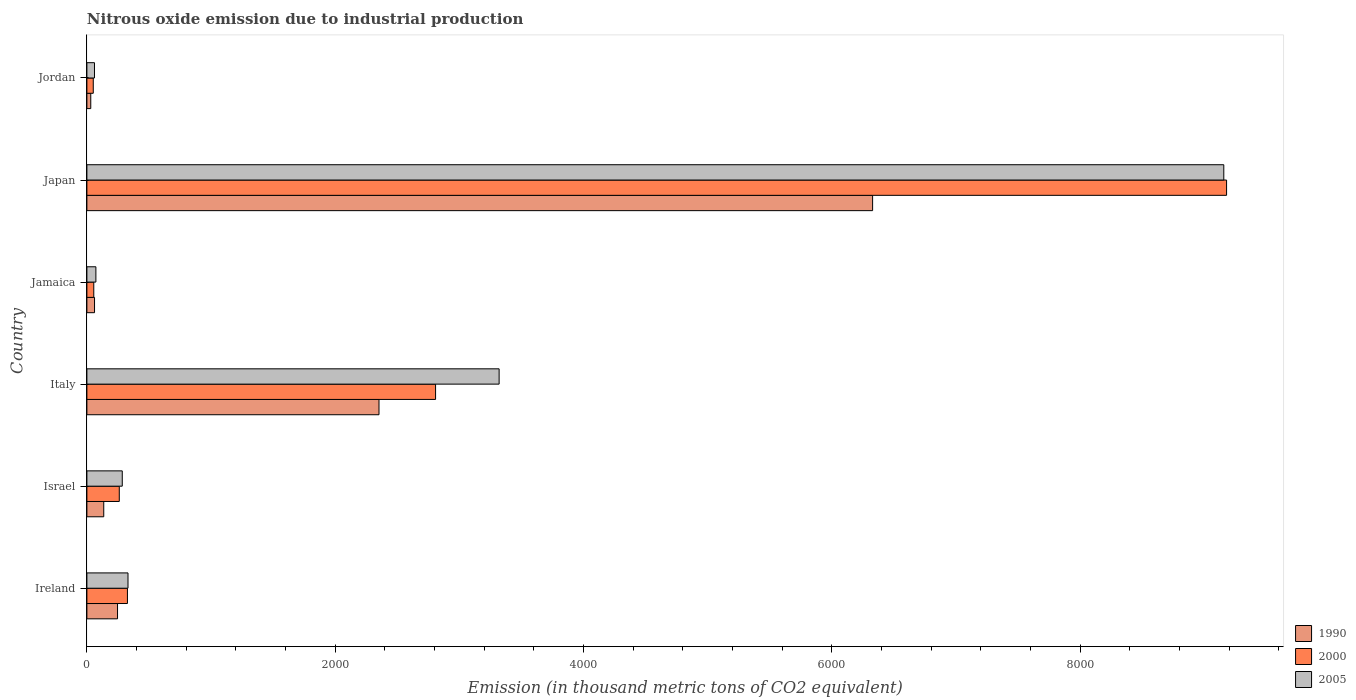How many groups of bars are there?
Your response must be concise. 6. Are the number of bars per tick equal to the number of legend labels?
Provide a succinct answer. Yes. Are the number of bars on each tick of the Y-axis equal?
Give a very brief answer. Yes. How many bars are there on the 5th tick from the top?
Your response must be concise. 3. In how many cases, is the number of bars for a given country not equal to the number of legend labels?
Offer a terse response. 0. What is the amount of nitrous oxide emitted in 2000 in Ireland?
Your answer should be very brief. 326.6. Across all countries, what is the maximum amount of nitrous oxide emitted in 1990?
Your answer should be very brief. 6328.4. Across all countries, what is the minimum amount of nitrous oxide emitted in 2005?
Keep it short and to the point. 61.1. In which country was the amount of nitrous oxide emitted in 2000 minimum?
Provide a succinct answer. Jordan. What is the total amount of nitrous oxide emitted in 1990 in the graph?
Provide a short and direct response. 9156.3. What is the difference between the amount of nitrous oxide emitted in 2000 in Italy and that in Japan?
Your answer should be compact. -6371. What is the difference between the amount of nitrous oxide emitted in 2000 in Japan and the amount of nitrous oxide emitted in 2005 in Jamaica?
Offer a terse response. 9107. What is the average amount of nitrous oxide emitted in 2000 per country?
Offer a very short reply. 2113.67. What is the difference between the amount of nitrous oxide emitted in 2000 and amount of nitrous oxide emitted in 1990 in Japan?
Your response must be concise. 2851. In how many countries, is the amount of nitrous oxide emitted in 2005 greater than 8400 thousand metric tons?
Your response must be concise. 1. What is the ratio of the amount of nitrous oxide emitted in 1990 in Israel to that in Jamaica?
Your answer should be very brief. 2.21. Is the amount of nitrous oxide emitted in 1990 in Ireland less than that in Jamaica?
Provide a short and direct response. No. What is the difference between the highest and the second highest amount of nitrous oxide emitted in 1990?
Offer a very short reply. 3975.7. What is the difference between the highest and the lowest amount of nitrous oxide emitted in 1990?
Offer a terse response. 6297.2. What does the 2nd bar from the top in Ireland represents?
Offer a very short reply. 2000. What does the 2nd bar from the bottom in Jamaica represents?
Your answer should be very brief. 2000. Is it the case that in every country, the sum of the amount of nitrous oxide emitted in 2005 and amount of nitrous oxide emitted in 1990 is greater than the amount of nitrous oxide emitted in 2000?
Your response must be concise. Yes. How many bars are there?
Provide a short and direct response. 18. How many countries are there in the graph?
Your answer should be compact. 6. What is the difference between two consecutive major ticks on the X-axis?
Offer a very short reply. 2000. Are the values on the major ticks of X-axis written in scientific E-notation?
Provide a short and direct response. No. Does the graph contain any zero values?
Provide a short and direct response. No. How are the legend labels stacked?
Offer a very short reply. Vertical. What is the title of the graph?
Offer a terse response. Nitrous oxide emission due to industrial production. Does "1966" appear as one of the legend labels in the graph?
Offer a very short reply. No. What is the label or title of the X-axis?
Your answer should be compact. Emission (in thousand metric tons of CO2 equivalent). What is the Emission (in thousand metric tons of CO2 equivalent) in 1990 in Ireland?
Your answer should be very brief. 246.7. What is the Emission (in thousand metric tons of CO2 equivalent) in 2000 in Ireland?
Ensure brevity in your answer.  326.6. What is the Emission (in thousand metric tons of CO2 equivalent) of 2005 in Ireland?
Ensure brevity in your answer.  331.1. What is the Emission (in thousand metric tons of CO2 equivalent) of 1990 in Israel?
Offer a very short reply. 135.8. What is the Emission (in thousand metric tons of CO2 equivalent) of 2000 in Israel?
Your answer should be very brief. 260.8. What is the Emission (in thousand metric tons of CO2 equivalent) of 2005 in Israel?
Make the answer very short. 284.9. What is the Emission (in thousand metric tons of CO2 equivalent) of 1990 in Italy?
Provide a succinct answer. 2352.7. What is the Emission (in thousand metric tons of CO2 equivalent) in 2000 in Italy?
Your answer should be compact. 2808.4. What is the Emission (in thousand metric tons of CO2 equivalent) in 2005 in Italy?
Ensure brevity in your answer.  3320.3. What is the Emission (in thousand metric tons of CO2 equivalent) in 1990 in Jamaica?
Your response must be concise. 61.5. What is the Emission (in thousand metric tons of CO2 equivalent) of 2000 in Jamaica?
Provide a short and direct response. 55.5. What is the Emission (in thousand metric tons of CO2 equivalent) in 2005 in Jamaica?
Your answer should be compact. 72.4. What is the Emission (in thousand metric tons of CO2 equivalent) of 1990 in Japan?
Your answer should be very brief. 6328.4. What is the Emission (in thousand metric tons of CO2 equivalent) of 2000 in Japan?
Offer a terse response. 9179.4. What is the Emission (in thousand metric tons of CO2 equivalent) in 2005 in Japan?
Ensure brevity in your answer.  9157. What is the Emission (in thousand metric tons of CO2 equivalent) of 1990 in Jordan?
Provide a succinct answer. 31.2. What is the Emission (in thousand metric tons of CO2 equivalent) in 2000 in Jordan?
Keep it short and to the point. 51.3. What is the Emission (in thousand metric tons of CO2 equivalent) of 2005 in Jordan?
Your response must be concise. 61.1. Across all countries, what is the maximum Emission (in thousand metric tons of CO2 equivalent) of 1990?
Provide a short and direct response. 6328.4. Across all countries, what is the maximum Emission (in thousand metric tons of CO2 equivalent) of 2000?
Offer a very short reply. 9179.4. Across all countries, what is the maximum Emission (in thousand metric tons of CO2 equivalent) in 2005?
Provide a short and direct response. 9157. Across all countries, what is the minimum Emission (in thousand metric tons of CO2 equivalent) of 1990?
Provide a succinct answer. 31.2. Across all countries, what is the minimum Emission (in thousand metric tons of CO2 equivalent) of 2000?
Your answer should be compact. 51.3. Across all countries, what is the minimum Emission (in thousand metric tons of CO2 equivalent) of 2005?
Provide a succinct answer. 61.1. What is the total Emission (in thousand metric tons of CO2 equivalent) of 1990 in the graph?
Offer a very short reply. 9156.3. What is the total Emission (in thousand metric tons of CO2 equivalent) in 2000 in the graph?
Keep it short and to the point. 1.27e+04. What is the total Emission (in thousand metric tons of CO2 equivalent) in 2005 in the graph?
Keep it short and to the point. 1.32e+04. What is the difference between the Emission (in thousand metric tons of CO2 equivalent) in 1990 in Ireland and that in Israel?
Your response must be concise. 110.9. What is the difference between the Emission (in thousand metric tons of CO2 equivalent) in 2000 in Ireland and that in Israel?
Offer a very short reply. 65.8. What is the difference between the Emission (in thousand metric tons of CO2 equivalent) in 2005 in Ireland and that in Israel?
Your answer should be compact. 46.2. What is the difference between the Emission (in thousand metric tons of CO2 equivalent) of 1990 in Ireland and that in Italy?
Offer a very short reply. -2106. What is the difference between the Emission (in thousand metric tons of CO2 equivalent) in 2000 in Ireland and that in Italy?
Provide a short and direct response. -2481.8. What is the difference between the Emission (in thousand metric tons of CO2 equivalent) in 2005 in Ireland and that in Italy?
Your response must be concise. -2989.2. What is the difference between the Emission (in thousand metric tons of CO2 equivalent) in 1990 in Ireland and that in Jamaica?
Your response must be concise. 185.2. What is the difference between the Emission (in thousand metric tons of CO2 equivalent) in 2000 in Ireland and that in Jamaica?
Your answer should be compact. 271.1. What is the difference between the Emission (in thousand metric tons of CO2 equivalent) in 2005 in Ireland and that in Jamaica?
Provide a succinct answer. 258.7. What is the difference between the Emission (in thousand metric tons of CO2 equivalent) of 1990 in Ireland and that in Japan?
Provide a short and direct response. -6081.7. What is the difference between the Emission (in thousand metric tons of CO2 equivalent) of 2000 in Ireland and that in Japan?
Provide a short and direct response. -8852.8. What is the difference between the Emission (in thousand metric tons of CO2 equivalent) in 2005 in Ireland and that in Japan?
Give a very brief answer. -8825.9. What is the difference between the Emission (in thousand metric tons of CO2 equivalent) in 1990 in Ireland and that in Jordan?
Your answer should be compact. 215.5. What is the difference between the Emission (in thousand metric tons of CO2 equivalent) in 2000 in Ireland and that in Jordan?
Ensure brevity in your answer.  275.3. What is the difference between the Emission (in thousand metric tons of CO2 equivalent) in 2005 in Ireland and that in Jordan?
Ensure brevity in your answer.  270. What is the difference between the Emission (in thousand metric tons of CO2 equivalent) in 1990 in Israel and that in Italy?
Your answer should be very brief. -2216.9. What is the difference between the Emission (in thousand metric tons of CO2 equivalent) in 2000 in Israel and that in Italy?
Keep it short and to the point. -2547.6. What is the difference between the Emission (in thousand metric tons of CO2 equivalent) of 2005 in Israel and that in Italy?
Keep it short and to the point. -3035.4. What is the difference between the Emission (in thousand metric tons of CO2 equivalent) in 1990 in Israel and that in Jamaica?
Provide a short and direct response. 74.3. What is the difference between the Emission (in thousand metric tons of CO2 equivalent) of 2000 in Israel and that in Jamaica?
Your answer should be compact. 205.3. What is the difference between the Emission (in thousand metric tons of CO2 equivalent) of 2005 in Israel and that in Jamaica?
Your answer should be very brief. 212.5. What is the difference between the Emission (in thousand metric tons of CO2 equivalent) in 1990 in Israel and that in Japan?
Provide a short and direct response. -6192.6. What is the difference between the Emission (in thousand metric tons of CO2 equivalent) of 2000 in Israel and that in Japan?
Offer a terse response. -8918.6. What is the difference between the Emission (in thousand metric tons of CO2 equivalent) of 2005 in Israel and that in Japan?
Provide a succinct answer. -8872.1. What is the difference between the Emission (in thousand metric tons of CO2 equivalent) in 1990 in Israel and that in Jordan?
Your response must be concise. 104.6. What is the difference between the Emission (in thousand metric tons of CO2 equivalent) of 2000 in Israel and that in Jordan?
Your answer should be very brief. 209.5. What is the difference between the Emission (in thousand metric tons of CO2 equivalent) of 2005 in Israel and that in Jordan?
Ensure brevity in your answer.  223.8. What is the difference between the Emission (in thousand metric tons of CO2 equivalent) of 1990 in Italy and that in Jamaica?
Your response must be concise. 2291.2. What is the difference between the Emission (in thousand metric tons of CO2 equivalent) in 2000 in Italy and that in Jamaica?
Ensure brevity in your answer.  2752.9. What is the difference between the Emission (in thousand metric tons of CO2 equivalent) in 2005 in Italy and that in Jamaica?
Keep it short and to the point. 3247.9. What is the difference between the Emission (in thousand metric tons of CO2 equivalent) in 1990 in Italy and that in Japan?
Your answer should be very brief. -3975.7. What is the difference between the Emission (in thousand metric tons of CO2 equivalent) of 2000 in Italy and that in Japan?
Your answer should be compact. -6371. What is the difference between the Emission (in thousand metric tons of CO2 equivalent) in 2005 in Italy and that in Japan?
Make the answer very short. -5836.7. What is the difference between the Emission (in thousand metric tons of CO2 equivalent) of 1990 in Italy and that in Jordan?
Make the answer very short. 2321.5. What is the difference between the Emission (in thousand metric tons of CO2 equivalent) in 2000 in Italy and that in Jordan?
Ensure brevity in your answer.  2757.1. What is the difference between the Emission (in thousand metric tons of CO2 equivalent) in 2005 in Italy and that in Jordan?
Provide a short and direct response. 3259.2. What is the difference between the Emission (in thousand metric tons of CO2 equivalent) of 1990 in Jamaica and that in Japan?
Your answer should be compact. -6266.9. What is the difference between the Emission (in thousand metric tons of CO2 equivalent) of 2000 in Jamaica and that in Japan?
Your answer should be compact. -9123.9. What is the difference between the Emission (in thousand metric tons of CO2 equivalent) in 2005 in Jamaica and that in Japan?
Give a very brief answer. -9084.6. What is the difference between the Emission (in thousand metric tons of CO2 equivalent) in 1990 in Jamaica and that in Jordan?
Ensure brevity in your answer.  30.3. What is the difference between the Emission (in thousand metric tons of CO2 equivalent) in 1990 in Japan and that in Jordan?
Offer a terse response. 6297.2. What is the difference between the Emission (in thousand metric tons of CO2 equivalent) of 2000 in Japan and that in Jordan?
Give a very brief answer. 9128.1. What is the difference between the Emission (in thousand metric tons of CO2 equivalent) of 2005 in Japan and that in Jordan?
Offer a terse response. 9095.9. What is the difference between the Emission (in thousand metric tons of CO2 equivalent) in 1990 in Ireland and the Emission (in thousand metric tons of CO2 equivalent) in 2000 in Israel?
Your answer should be very brief. -14.1. What is the difference between the Emission (in thousand metric tons of CO2 equivalent) of 1990 in Ireland and the Emission (in thousand metric tons of CO2 equivalent) of 2005 in Israel?
Your response must be concise. -38.2. What is the difference between the Emission (in thousand metric tons of CO2 equivalent) of 2000 in Ireland and the Emission (in thousand metric tons of CO2 equivalent) of 2005 in Israel?
Offer a very short reply. 41.7. What is the difference between the Emission (in thousand metric tons of CO2 equivalent) in 1990 in Ireland and the Emission (in thousand metric tons of CO2 equivalent) in 2000 in Italy?
Keep it short and to the point. -2561.7. What is the difference between the Emission (in thousand metric tons of CO2 equivalent) in 1990 in Ireland and the Emission (in thousand metric tons of CO2 equivalent) in 2005 in Italy?
Keep it short and to the point. -3073.6. What is the difference between the Emission (in thousand metric tons of CO2 equivalent) of 2000 in Ireland and the Emission (in thousand metric tons of CO2 equivalent) of 2005 in Italy?
Your answer should be compact. -2993.7. What is the difference between the Emission (in thousand metric tons of CO2 equivalent) of 1990 in Ireland and the Emission (in thousand metric tons of CO2 equivalent) of 2000 in Jamaica?
Make the answer very short. 191.2. What is the difference between the Emission (in thousand metric tons of CO2 equivalent) in 1990 in Ireland and the Emission (in thousand metric tons of CO2 equivalent) in 2005 in Jamaica?
Offer a very short reply. 174.3. What is the difference between the Emission (in thousand metric tons of CO2 equivalent) of 2000 in Ireland and the Emission (in thousand metric tons of CO2 equivalent) of 2005 in Jamaica?
Keep it short and to the point. 254.2. What is the difference between the Emission (in thousand metric tons of CO2 equivalent) of 1990 in Ireland and the Emission (in thousand metric tons of CO2 equivalent) of 2000 in Japan?
Your answer should be very brief. -8932.7. What is the difference between the Emission (in thousand metric tons of CO2 equivalent) of 1990 in Ireland and the Emission (in thousand metric tons of CO2 equivalent) of 2005 in Japan?
Your answer should be compact. -8910.3. What is the difference between the Emission (in thousand metric tons of CO2 equivalent) of 2000 in Ireland and the Emission (in thousand metric tons of CO2 equivalent) of 2005 in Japan?
Give a very brief answer. -8830.4. What is the difference between the Emission (in thousand metric tons of CO2 equivalent) of 1990 in Ireland and the Emission (in thousand metric tons of CO2 equivalent) of 2000 in Jordan?
Your answer should be compact. 195.4. What is the difference between the Emission (in thousand metric tons of CO2 equivalent) in 1990 in Ireland and the Emission (in thousand metric tons of CO2 equivalent) in 2005 in Jordan?
Offer a terse response. 185.6. What is the difference between the Emission (in thousand metric tons of CO2 equivalent) of 2000 in Ireland and the Emission (in thousand metric tons of CO2 equivalent) of 2005 in Jordan?
Make the answer very short. 265.5. What is the difference between the Emission (in thousand metric tons of CO2 equivalent) of 1990 in Israel and the Emission (in thousand metric tons of CO2 equivalent) of 2000 in Italy?
Your response must be concise. -2672.6. What is the difference between the Emission (in thousand metric tons of CO2 equivalent) in 1990 in Israel and the Emission (in thousand metric tons of CO2 equivalent) in 2005 in Italy?
Provide a succinct answer. -3184.5. What is the difference between the Emission (in thousand metric tons of CO2 equivalent) in 2000 in Israel and the Emission (in thousand metric tons of CO2 equivalent) in 2005 in Italy?
Ensure brevity in your answer.  -3059.5. What is the difference between the Emission (in thousand metric tons of CO2 equivalent) in 1990 in Israel and the Emission (in thousand metric tons of CO2 equivalent) in 2000 in Jamaica?
Your response must be concise. 80.3. What is the difference between the Emission (in thousand metric tons of CO2 equivalent) in 1990 in Israel and the Emission (in thousand metric tons of CO2 equivalent) in 2005 in Jamaica?
Give a very brief answer. 63.4. What is the difference between the Emission (in thousand metric tons of CO2 equivalent) in 2000 in Israel and the Emission (in thousand metric tons of CO2 equivalent) in 2005 in Jamaica?
Your response must be concise. 188.4. What is the difference between the Emission (in thousand metric tons of CO2 equivalent) in 1990 in Israel and the Emission (in thousand metric tons of CO2 equivalent) in 2000 in Japan?
Offer a terse response. -9043.6. What is the difference between the Emission (in thousand metric tons of CO2 equivalent) of 1990 in Israel and the Emission (in thousand metric tons of CO2 equivalent) of 2005 in Japan?
Offer a terse response. -9021.2. What is the difference between the Emission (in thousand metric tons of CO2 equivalent) of 2000 in Israel and the Emission (in thousand metric tons of CO2 equivalent) of 2005 in Japan?
Make the answer very short. -8896.2. What is the difference between the Emission (in thousand metric tons of CO2 equivalent) in 1990 in Israel and the Emission (in thousand metric tons of CO2 equivalent) in 2000 in Jordan?
Provide a succinct answer. 84.5. What is the difference between the Emission (in thousand metric tons of CO2 equivalent) in 1990 in Israel and the Emission (in thousand metric tons of CO2 equivalent) in 2005 in Jordan?
Provide a succinct answer. 74.7. What is the difference between the Emission (in thousand metric tons of CO2 equivalent) in 2000 in Israel and the Emission (in thousand metric tons of CO2 equivalent) in 2005 in Jordan?
Your response must be concise. 199.7. What is the difference between the Emission (in thousand metric tons of CO2 equivalent) of 1990 in Italy and the Emission (in thousand metric tons of CO2 equivalent) of 2000 in Jamaica?
Make the answer very short. 2297.2. What is the difference between the Emission (in thousand metric tons of CO2 equivalent) in 1990 in Italy and the Emission (in thousand metric tons of CO2 equivalent) in 2005 in Jamaica?
Provide a succinct answer. 2280.3. What is the difference between the Emission (in thousand metric tons of CO2 equivalent) of 2000 in Italy and the Emission (in thousand metric tons of CO2 equivalent) of 2005 in Jamaica?
Provide a short and direct response. 2736. What is the difference between the Emission (in thousand metric tons of CO2 equivalent) of 1990 in Italy and the Emission (in thousand metric tons of CO2 equivalent) of 2000 in Japan?
Provide a short and direct response. -6826.7. What is the difference between the Emission (in thousand metric tons of CO2 equivalent) of 1990 in Italy and the Emission (in thousand metric tons of CO2 equivalent) of 2005 in Japan?
Your response must be concise. -6804.3. What is the difference between the Emission (in thousand metric tons of CO2 equivalent) of 2000 in Italy and the Emission (in thousand metric tons of CO2 equivalent) of 2005 in Japan?
Your response must be concise. -6348.6. What is the difference between the Emission (in thousand metric tons of CO2 equivalent) in 1990 in Italy and the Emission (in thousand metric tons of CO2 equivalent) in 2000 in Jordan?
Give a very brief answer. 2301.4. What is the difference between the Emission (in thousand metric tons of CO2 equivalent) of 1990 in Italy and the Emission (in thousand metric tons of CO2 equivalent) of 2005 in Jordan?
Your response must be concise. 2291.6. What is the difference between the Emission (in thousand metric tons of CO2 equivalent) of 2000 in Italy and the Emission (in thousand metric tons of CO2 equivalent) of 2005 in Jordan?
Your response must be concise. 2747.3. What is the difference between the Emission (in thousand metric tons of CO2 equivalent) of 1990 in Jamaica and the Emission (in thousand metric tons of CO2 equivalent) of 2000 in Japan?
Offer a very short reply. -9117.9. What is the difference between the Emission (in thousand metric tons of CO2 equivalent) of 1990 in Jamaica and the Emission (in thousand metric tons of CO2 equivalent) of 2005 in Japan?
Offer a very short reply. -9095.5. What is the difference between the Emission (in thousand metric tons of CO2 equivalent) in 2000 in Jamaica and the Emission (in thousand metric tons of CO2 equivalent) in 2005 in Japan?
Provide a short and direct response. -9101.5. What is the difference between the Emission (in thousand metric tons of CO2 equivalent) in 1990 in Jamaica and the Emission (in thousand metric tons of CO2 equivalent) in 2000 in Jordan?
Your answer should be compact. 10.2. What is the difference between the Emission (in thousand metric tons of CO2 equivalent) of 1990 in Japan and the Emission (in thousand metric tons of CO2 equivalent) of 2000 in Jordan?
Your answer should be very brief. 6277.1. What is the difference between the Emission (in thousand metric tons of CO2 equivalent) of 1990 in Japan and the Emission (in thousand metric tons of CO2 equivalent) of 2005 in Jordan?
Provide a succinct answer. 6267.3. What is the difference between the Emission (in thousand metric tons of CO2 equivalent) of 2000 in Japan and the Emission (in thousand metric tons of CO2 equivalent) of 2005 in Jordan?
Provide a succinct answer. 9118.3. What is the average Emission (in thousand metric tons of CO2 equivalent) in 1990 per country?
Ensure brevity in your answer.  1526.05. What is the average Emission (in thousand metric tons of CO2 equivalent) in 2000 per country?
Make the answer very short. 2113.67. What is the average Emission (in thousand metric tons of CO2 equivalent) in 2005 per country?
Provide a succinct answer. 2204.47. What is the difference between the Emission (in thousand metric tons of CO2 equivalent) of 1990 and Emission (in thousand metric tons of CO2 equivalent) of 2000 in Ireland?
Your answer should be compact. -79.9. What is the difference between the Emission (in thousand metric tons of CO2 equivalent) in 1990 and Emission (in thousand metric tons of CO2 equivalent) in 2005 in Ireland?
Provide a short and direct response. -84.4. What is the difference between the Emission (in thousand metric tons of CO2 equivalent) in 1990 and Emission (in thousand metric tons of CO2 equivalent) in 2000 in Israel?
Give a very brief answer. -125. What is the difference between the Emission (in thousand metric tons of CO2 equivalent) in 1990 and Emission (in thousand metric tons of CO2 equivalent) in 2005 in Israel?
Keep it short and to the point. -149.1. What is the difference between the Emission (in thousand metric tons of CO2 equivalent) in 2000 and Emission (in thousand metric tons of CO2 equivalent) in 2005 in Israel?
Your answer should be compact. -24.1. What is the difference between the Emission (in thousand metric tons of CO2 equivalent) of 1990 and Emission (in thousand metric tons of CO2 equivalent) of 2000 in Italy?
Offer a terse response. -455.7. What is the difference between the Emission (in thousand metric tons of CO2 equivalent) of 1990 and Emission (in thousand metric tons of CO2 equivalent) of 2005 in Italy?
Ensure brevity in your answer.  -967.6. What is the difference between the Emission (in thousand metric tons of CO2 equivalent) in 2000 and Emission (in thousand metric tons of CO2 equivalent) in 2005 in Italy?
Provide a succinct answer. -511.9. What is the difference between the Emission (in thousand metric tons of CO2 equivalent) of 1990 and Emission (in thousand metric tons of CO2 equivalent) of 2000 in Jamaica?
Make the answer very short. 6. What is the difference between the Emission (in thousand metric tons of CO2 equivalent) in 1990 and Emission (in thousand metric tons of CO2 equivalent) in 2005 in Jamaica?
Your answer should be very brief. -10.9. What is the difference between the Emission (in thousand metric tons of CO2 equivalent) of 2000 and Emission (in thousand metric tons of CO2 equivalent) of 2005 in Jamaica?
Keep it short and to the point. -16.9. What is the difference between the Emission (in thousand metric tons of CO2 equivalent) of 1990 and Emission (in thousand metric tons of CO2 equivalent) of 2000 in Japan?
Keep it short and to the point. -2851. What is the difference between the Emission (in thousand metric tons of CO2 equivalent) in 1990 and Emission (in thousand metric tons of CO2 equivalent) in 2005 in Japan?
Keep it short and to the point. -2828.6. What is the difference between the Emission (in thousand metric tons of CO2 equivalent) of 2000 and Emission (in thousand metric tons of CO2 equivalent) of 2005 in Japan?
Provide a short and direct response. 22.4. What is the difference between the Emission (in thousand metric tons of CO2 equivalent) of 1990 and Emission (in thousand metric tons of CO2 equivalent) of 2000 in Jordan?
Ensure brevity in your answer.  -20.1. What is the difference between the Emission (in thousand metric tons of CO2 equivalent) in 1990 and Emission (in thousand metric tons of CO2 equivalent) in 2005 in Jordan?
Your response must be concise. -29.9. What is the difference between the Emission (in thousand metric tons of CO2 equivalent) of 2000 and Emission (in thousand metric tons of CO2 equivalent) of 2005 in Jordan?
Your answer should be compact. -9.8. What is the ratio of the Emission (in thousand metric tons of CO2 equivalent) in 1990 in Ireland to that in Israel?
Offer a terse response. 1.82. What is the ratio of the Emission (in thousand metric tons of CO2 equivalent) of 2000 in Ireland to that in Israel?
Offer a very short reply. 1.25. What is the ratio of the Emission (in thousand metric tons of CO2 equivalent) in 2005 in Ireland to that in Israel?
Your answer should be very brief. 1.16. What is the ratio of the Emission (in thousand metric tons of CO2 equivalent) of 1990 in Ireland to that in Italy?
Provide a short and direct response. 0.1. What is the ratio of the Emission (in thousand metric tons of CO2 equivalent) of 2000 in Ireland to that in Italy?
Give a very brief answer. 0.12. What is the ratio of the Emission (in thousand metric tons of CO2 equivalent) of 2005 in Ireland to that in Italy?
Your answer should be very brief. 0.1. What is the ratio of the Emission (in thousand metric tons of CO2 equivalent) of 1990 in Ireland to that in Jamaica?
Keep it short and to the point. 4.01. What is the ratio of the Emission (in thousand metric tons of CO2 equivalent) of 2000 in Ireland to that in Jamaica?
Offer a terse response. 5.88. What is the ratio of the Emission (in thousand metric tons of CO2 equivalent) of 2005 in Ireland to that in Jamaica?
Keep it short and to the point. 4.57. What is the ratio of the Emission (in thousand metric tons of CO2 equivalent) in 1990 in Ireland to that in Japan?
Offer a very short reply. 0.04. What is the ratio of the Emission (in thousand metric tons of CO2 equivalent) of 2000 in Ireland to that in Japan?
Ensure brevity in your answer.  0.04. What is the ratio of the Emission (in thousand metric tons of CO2 equivalent) of 2005 in Ireland to that in Japan?
Give a very brief answer. 0.04. What is the ratio of the Emission (in thousand metric tons of CO2 equivalent) of 1990 in Ireland to that in Jordan?
Keep it short and to the point. 7.91. What is the ratio of the Emission (in thousand metric tons of CO2 equivalent) in 2000 in Ireland to that in Jordan?
Offer a very short reply. 6.37. What is the ratio of the Emission (in thousand metric tons of CO2 equivalent) of 2005 in Ireland to that in Jordan?
Offer a very short reply. 5.42. What is the ratio of the Emission (in thousand metric tons of CO2 equivalent) of 1990 in Israel to that in Italy?
Offer a very short reply. 0.06. What is the ratio of the Emission (in thousand metric tons of CO2 equivalent) in 2000 in Israel to that in Italy?
Your answer should be compact. 0.09. What is the ratio of the Emission (in thousand metric tons of CO2 equivalent) of 2005 in Israel to that in Italy?
Offer a terse response. 0.09. What is the ratio of the Emission (in thousand metric tons of CO2 equivalent) in 1990 in Israel to that in Jamaica?
Offer a very short reply. 2.21. What is the ratio of the Emission (in thousand metric tons of CO2 equivalent) in 2000 in Israel to that in Jamaica?
Keep it short and to the point. 4.7. What is the ratio of the Emission (in thousand metric tons of CO2 equivalent) of 2005 in Israel to that in Jamaica?
Ensure brevity in your answer.  3.94. What is the ratio of the Emission (in thousand metric tons of CO2 equivalent) of 1990 in Israel to that in Japan?
Make the answer very short. 0.02. What is the ratio of the Emission (in thousand metric tons of CO2 equivalent) of 2000 in Israel to that in Japan?
Make the answer very short. 0.03. What is the ratio of the Emission (in thousand metric tons of CO2 equivalent) in 2005 in Israel to that in Japan?
Give a very brief answer. 0.03. What is the ratio of the Emission (in thousand metric tons of CO2 equivalent) of 1990 in Israel to that in Jordan?
Make the answer very short. 4.35. What is the ratio of the Emission (in thousand metric tons of CO2 equivalent) of 2000 in Israel to that in Jordan?
Your response must be concise. 5.08. What is the ratio of the Emission (in thousand metric tons of CO2 equivalent) in 2005 in Israel to that in Jordan?
Ensure brevity in your answer.  4.66. What is the ratio of the Emission (in thousand metric tons of CO2 equivalent) of 1990 in Italy to that in Jamaica?
Offer a very short reply. 38.26. What is the ratio of the Emission (in thousand metric tons of CO2 equivalent) of 2000 in Italy to that in Jamaica?
Provide a short and direct response. 50.6. What is the ratio of the Emission (in thousand metric tons of CO2 equivalent) in 2005 in Italy to that in Jamaica?
Offer a very short reply. 45.86. What is the ratio of the Emission (in thousand metric tons of CO2 equivalent) in 1990 in Italy to that in Japan?
Offer a terse response. 0.37. What is the ratio of the Emission (in thousand metric tons of CO2 equivalent) of 2000 in Italy to that in Japan?
Give a very brief answer. 0.31. What is the ratio of the Emission (in thousand metric tons of CO2 equivalent) of 2005 in Italy to that in Japan?
Ensure brevity in your answer.  0.36. What is the ratio of the Emission (in thousand metric tons of CO2 equivalent) in 1990 in Italy to that in Jordan?
Your answer should be very brief. 75.41. What is the ratio of the Emission (in thousand metric tons of CO2 equivalent) of 2000 in Italy to that in Jordan?
Your answer should be very brief. 54.74. What is the ratio of the Emission (in thousand metric tons of CO2 equivalent) in 2005 in Italy to that in Jordan?
Offer a terse response. 54.34. What is the ratio of the Emission (in thousand metric tons of CO2 equivalent) of 1990 in Jamaica to that in Japan?
Your response must be concise. 0.01. What is the ratio of the Emission (in thousand metric tons of CO2 equivalent) in 2000 in Jamaica to that in Japan?
Keep it short and to the point. 0.01. What is the ratio of the Emission (in thousand metric tons of CO2 equivalent) in 2005 in Jamaica to that in Japan?
Your response must be concise. 0.01. What is the ratio of the Emission (in thousand metric tons of CO2 equivalent) of 1990 in Jamaica to that in Jordan?
Make the answer very short. 1.97. What is the ratio of the Emission (in thousand metric tons of CO2 equivalent) in 2000 in Jamaica to that in Jordan?
Your response must be concise. 1.08. What is the ratio of the Emission (in thousand metric tons of CO2 equivalent) of 2005 in Jamaica to that in Jordan?
Ensure brevity in your answer.  1.18. What is the ratio of the Emission (in thousand metric tons of CO2 equivalent) in 1990 in Japan to that in Jordan?
Make the answer very short. 202.83. What is the ratio of the Emission (in thousand metric tons of CO2 equivalent) of 2000 in Japan to that in Jordan?
Give a very brief answer. 178.94. What is the ratio of the Emission (in thousand metric tons of CO2 equivalent) of 2005 in Japan to that in Jordan?
Make the answer very short. 149.87. What is the difference between the highest and the second highest Emission (in thousand metric tons of CO2 equivalent) of 1990?
Make the answer very short. 3975.7. What is the difference between the highest and the second highest Emission (in thousand metric tons of CO2 equivalent) of 2000?
Your response must be concise. 6371. What is the difference between the highest and the second highest Emission (in thousand metric tons of CO2 equivalent) of 2005?
Your response must be concise. 5836.7. What is the difference between the highest and the lowest Emission (in thousand metric tons of CO2 equivalent) in 1990?
Your response must be concise. 6297.2. What is the difference between the highest and the lowest Emission (in thousand metric tons of CO2 equivalent) of 2000?
Offer a terse response. 9128.1. What is the difference between the highest and the lowest Emission (in thousand metric tons of CO2 equivalent) in 2005?
Your answer should be very brief. 9095.9. 